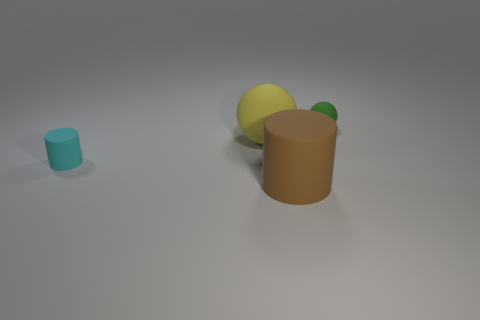There is a cyan object that is the same shape as the brown rubber thing; what is it made of?
Your answer should be very brief. Rubber. The small rubber cylinder has what color?
Keep it short and to the point. Cyan. Does the small sphere have the same color as the tiny matte cylinder?
Provide a short and direct response. No. What number of metal things are big brown balls or tiny cyan cylinders?
Your response must be concise. 0. Is there a small cyan rubber cylinder that is left of the rubber cylinder that is behind the brown rubber thing that is to the right of the big yellow matte object?
Provide a succinct answer. No. There is a yellow thing that is made of the same material as the green object; what is its size?
Provide a succinct answer. Large. There is a small green thing; are there any matte objects in front of it?
Your answer should be very brief. Yes. There is a tiny rubber thing in front of the tiny green object; is there a large cylinder to the left of it?
Make the answer very short. No. Is the size of the cylinder right of the cyan thing the same as the ball in front of the small sphere?
Keep it short and to the point. Yes. How many tiny objects are either rubber objects or matte balls?
Your response must be concise. 2. 